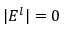<formula> <loc_0><loc_0><loc_500><loc_500>| E ^ { l } | = 0</formula> 